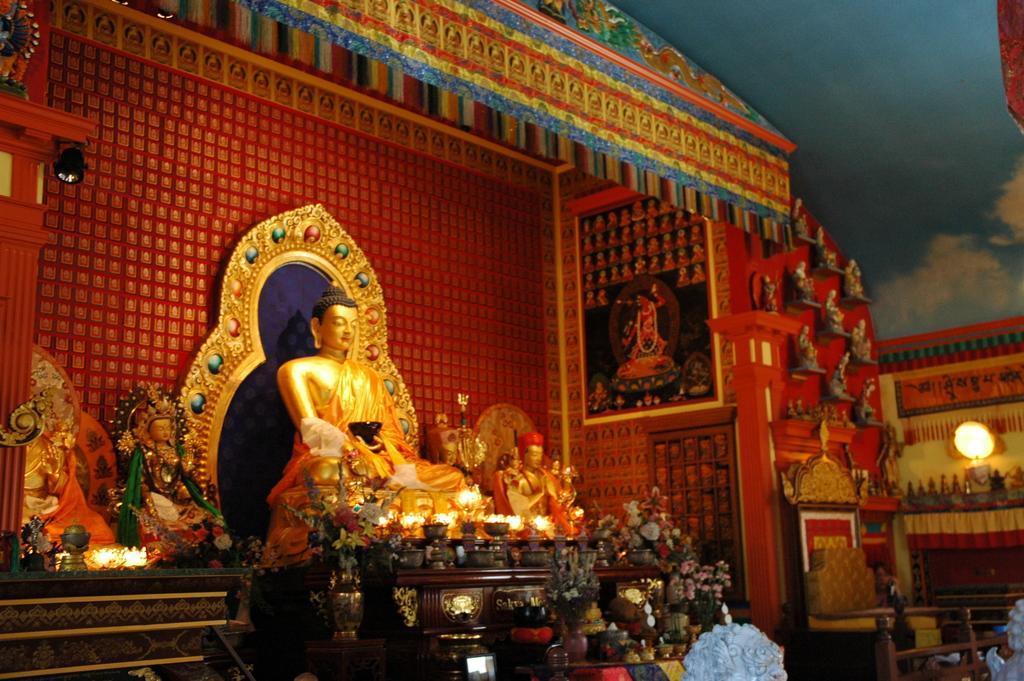How would you summarize this image in a sentence or two? In the picture we can see an interior of the Chinese temple with a lord Buddha and some decorated wall and some arts on it and beside we can see a wall with a light on it. 